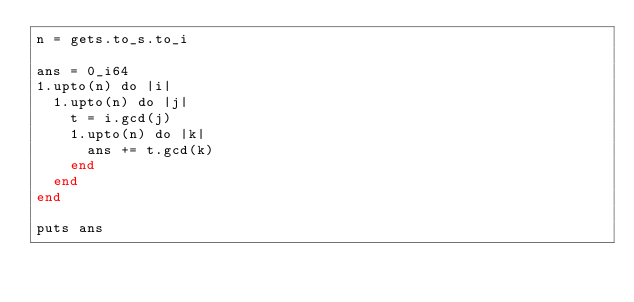Convert code to text. <code><loc_0><loc_0><loc_500><loc_500><_Crystal_>n = gets.to_s.to_i
 
ans = 0_i64
1.upto(n) do |i|
  1.upto(n) do |j|
    t = i.gcd(j)
    1.upto(n) do |k|
      ans += t.gcd(k)
    end
  end
end
 
puts ans</code> 